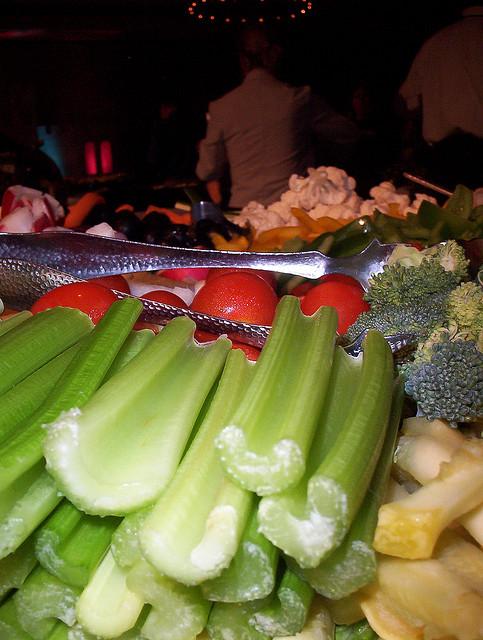What are the red vegetables?
Short answer required. Tomatoes. How are the yellow and green vegetables similar?
Short answer required. Cut. Is this a restaurant?
Short answer required. Yes. Could this be a fresh vegetable tray?
Concise answer only. Yes. 